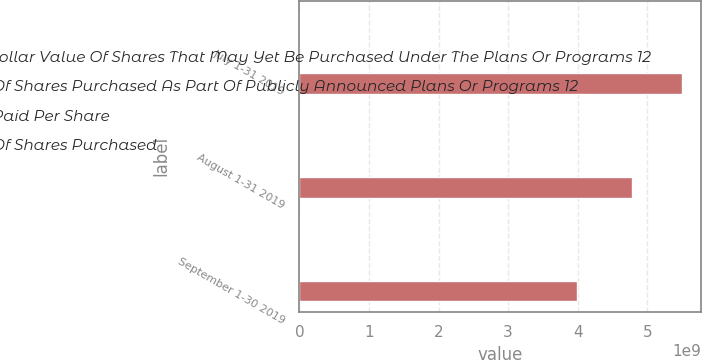<chart> <loc_0><loc_0><loc_500><loc_500><stacked_bar_chart><ecel><fcel>July 1-31 2019<fcel>August 1-31 2019<fcel>September 1-30 2019<nl><fcel>Approximate Dollar Value Of Shares That May Yet Be Purchased Under The Plans Or Programs 12<fcel>3.6801e+06<fcel>4.0648e+06<fcel>4.4795e+06<nl><fcel>Total Number Of Shares Purchased As Part Of Publicly Announced Plans Or Programs 12<fcel>179.32<fcel>176.17<fcel>176.61<nl><fcel>Average Price Paid Per Share<fcel>3.6801e+06<fcel>4.0648e+06<fcel>4.4795e+06<nl><fcel>Total Number Of Shares Purchased<fcel>5.50243e+09<fcel>4.78627e+09<fcel>3.99505e+09<nl></chart> 